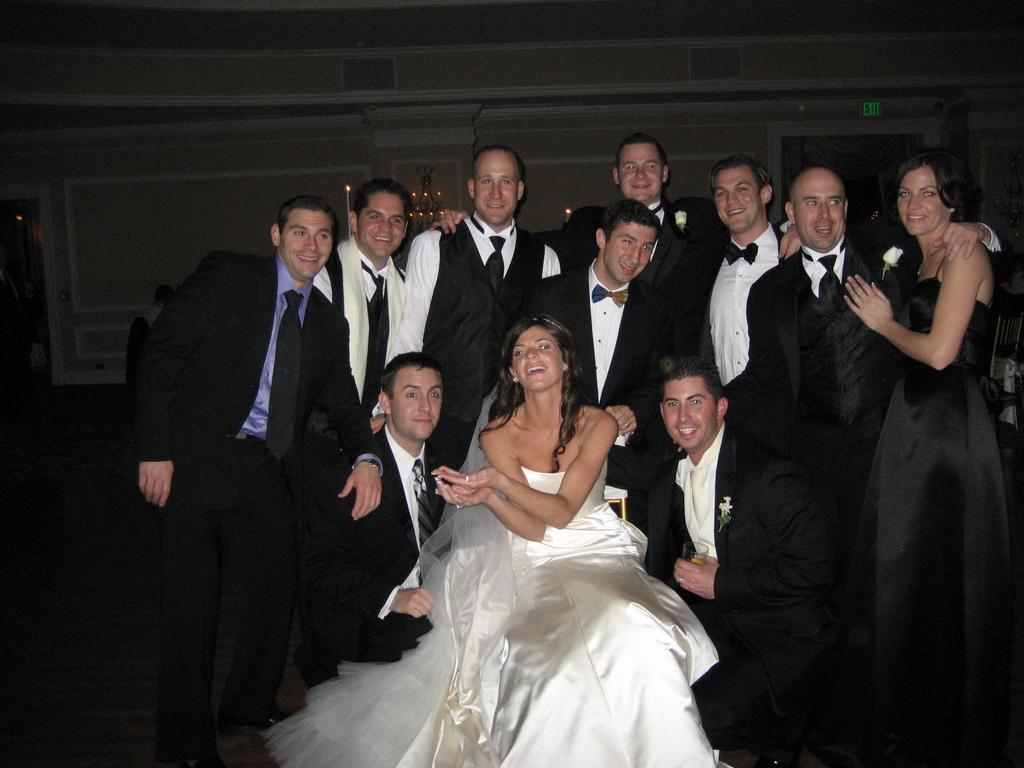Can you describe this image briefly? In the center of the image we can see a woman sitting on a chair and two men sitting on their knees beside her. We can also see a group of people standing. On the backside we can see some candles with the flame, the signboard and a wall. 